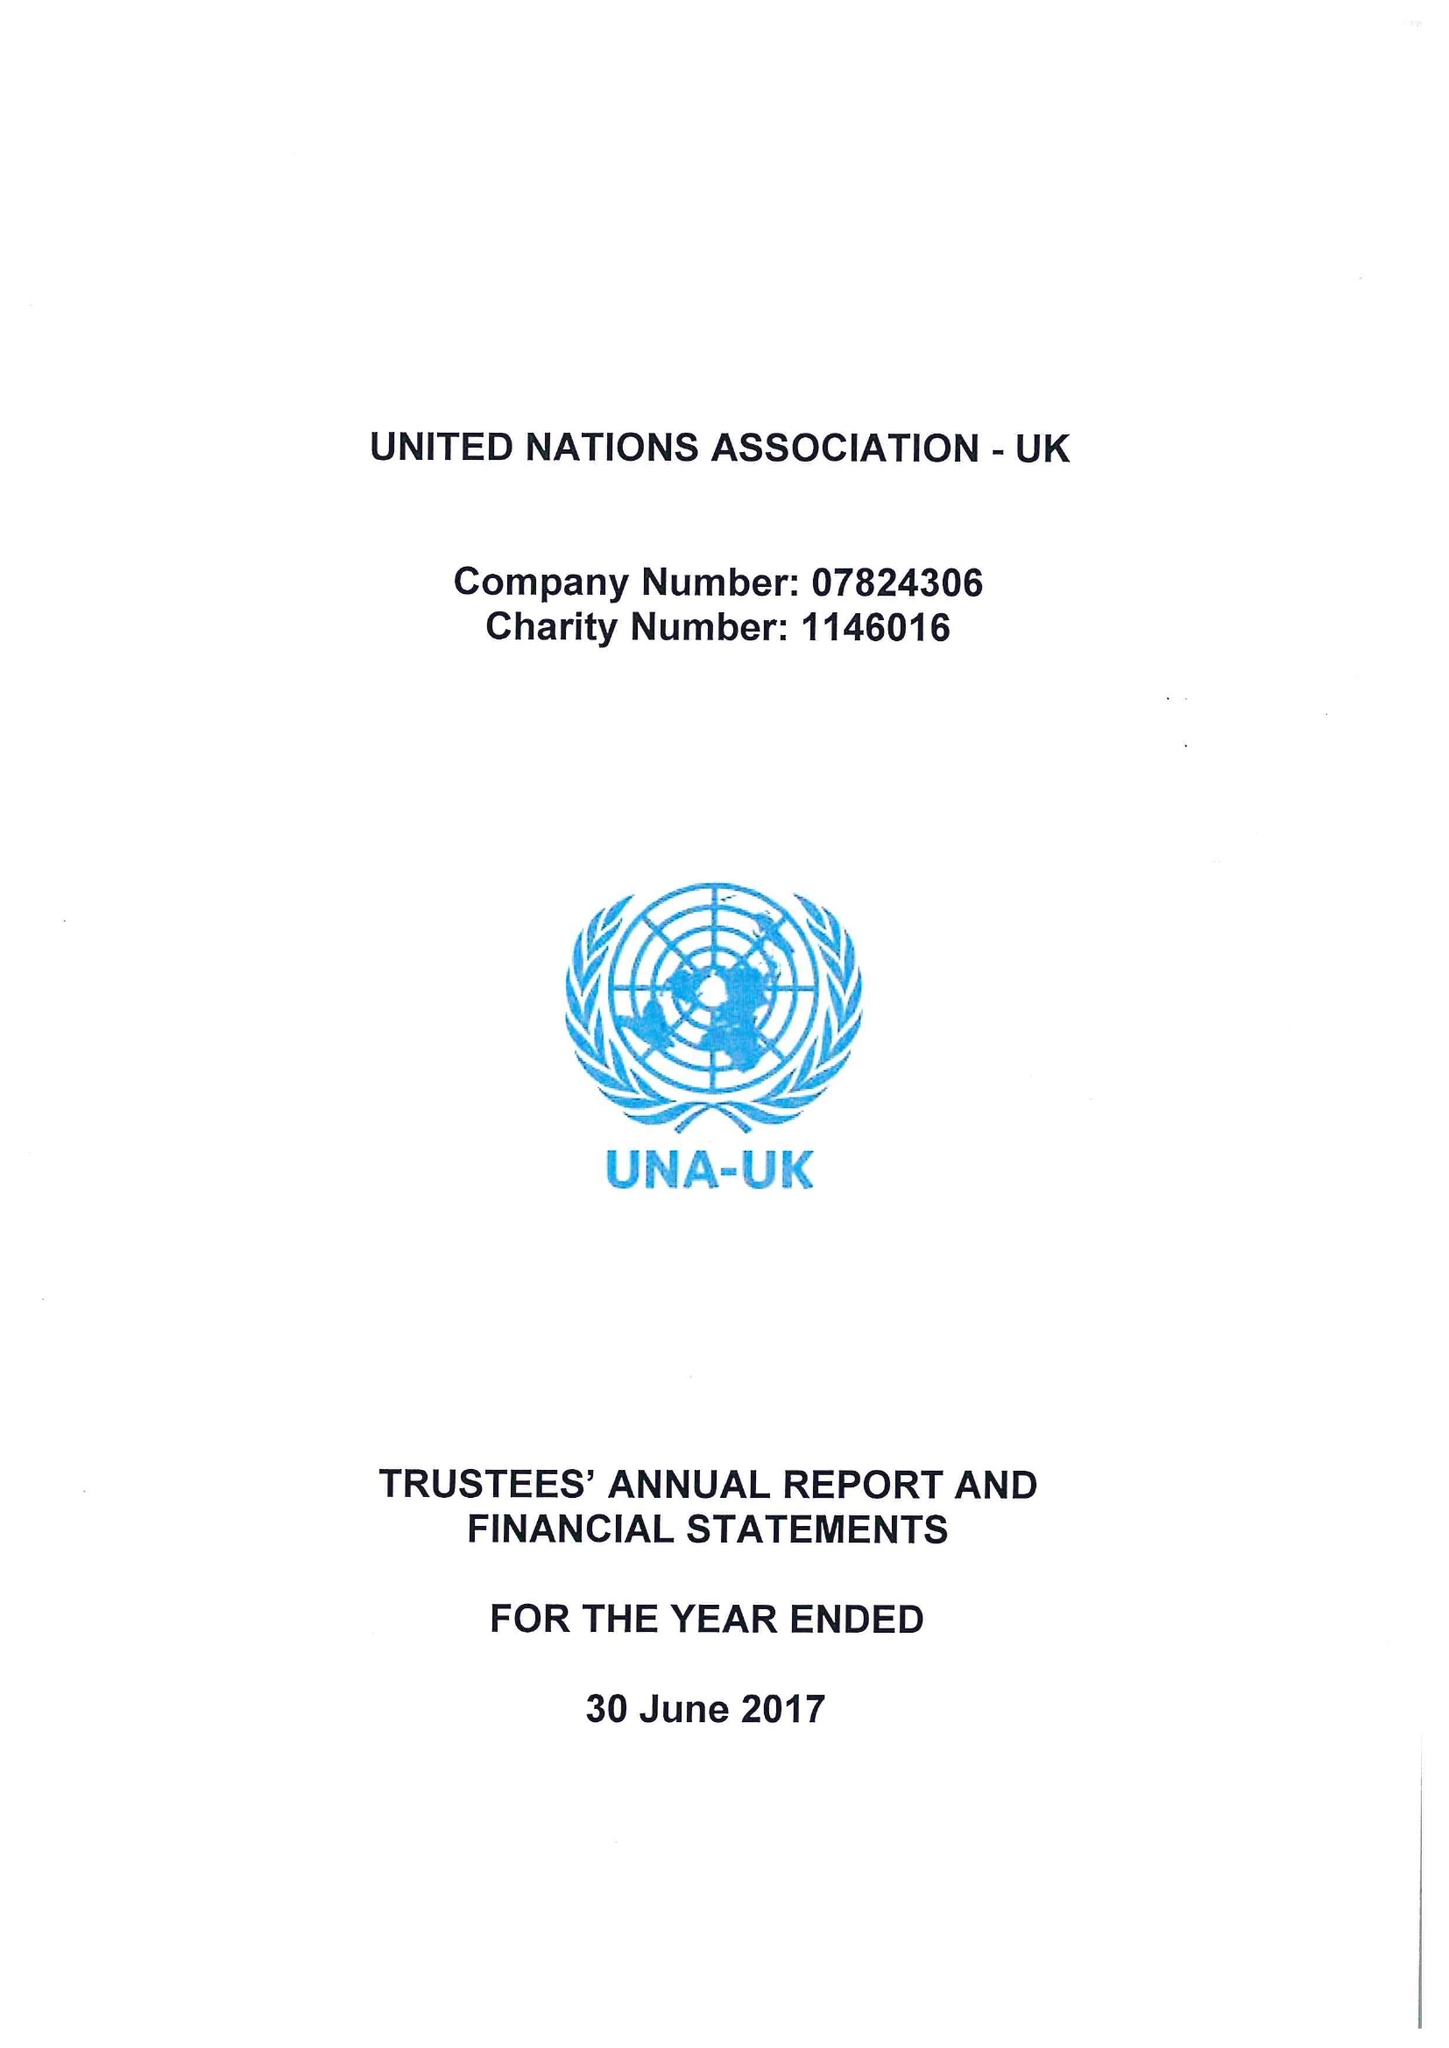What is the value for the spending_annually_in_british_pounds?
Answer the question using a single word or phrase. 479373.00 